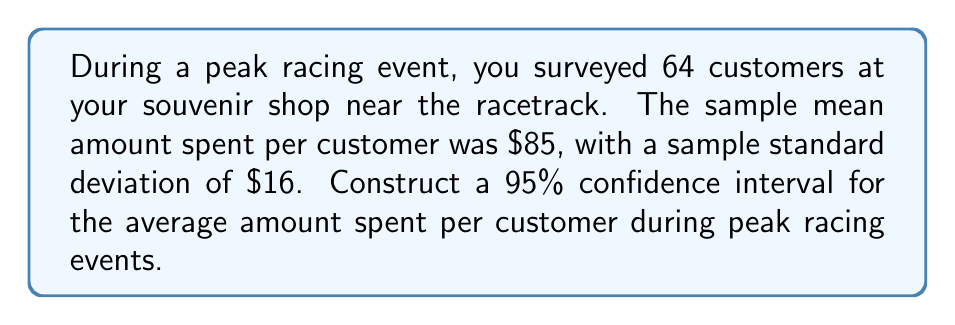Help me with this question. To construct a 95% confidence interval, we'll follow these steps:

1) We use the formula: $\bar{x} \pm t_{\alpha/2} \cdot \frac{s}{\sqrt{n}}$

   Where:
   $\bar{x}$ is the sample mean
   $t_{\alpha/2}$ is the t-value for a 95% confidence level with n-1 degrees of freedom
   $s$ is the sample standard deviation
   $n$ is the sample size

2) We know:
   $\bar{x} = 85$
   $s = 16$
   $n = 64$
   Confidence level = 95%, so $\alpha = 0.05$

3) Degrees of freedom = $n - 1 = 64 - 1 = 63$

4) From a t-table, we find $t_{0.025, 63} \approx 2.000$ for a two-tailed test with 63 degrees of freedom

5) Now we can calculate:

   $85 \pm 2.000 \cdot \frac{16}{\sqrt{64}}$

   $= 85 \pm 2.000 \cdot \frac{16}{8}$

   $= 85 \pm 2.000 \cdot 2$

   $= 85 \pm 4$

6) Therefore, the 95% confidence interval is $(81, 89)$
Answer: $(81, 89)$ 